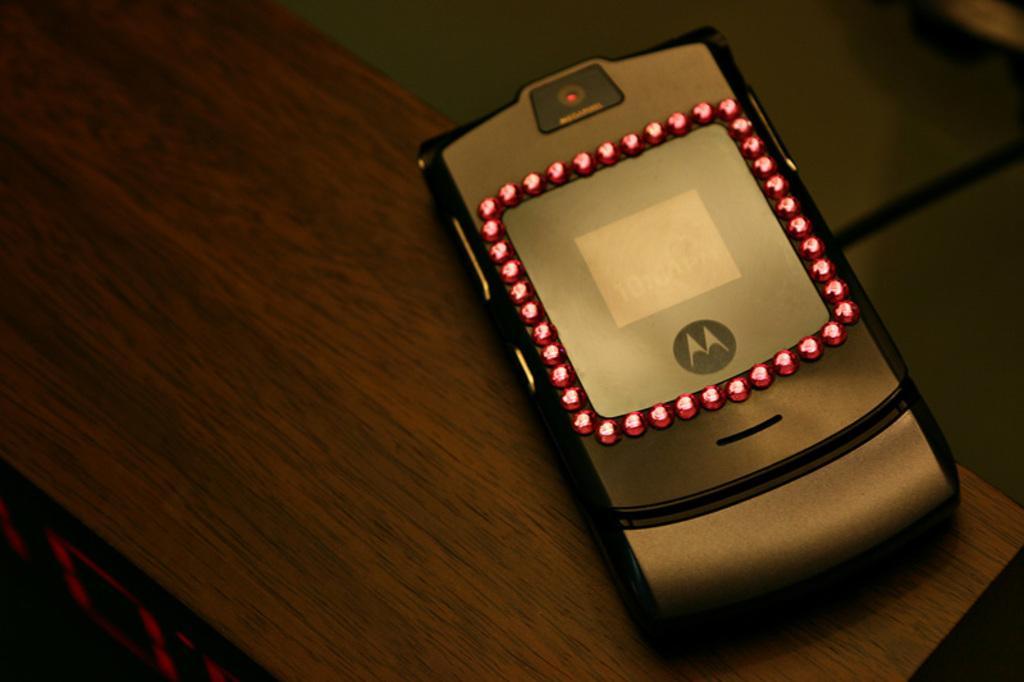Can you describe this image briefly? In this picture we can see a mobile on a platform. 